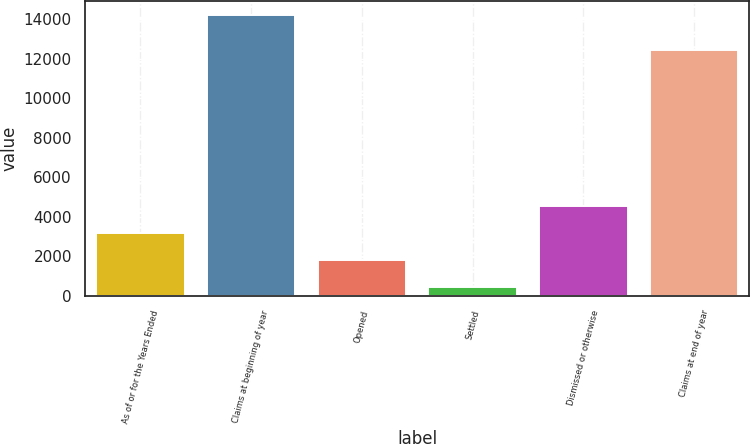Convert chart. <chart><loc_0><loc_0><loc_500><loc_500><bar_chart><fcel>As of or for the Years Ended<fcel>Claims at beginning of year<fcel>Opened<fcel>Settled<fcel>Dismissed or otherwise<fcel>Claims at end of year<nl><fcel>3183.8<fcel>14215<fcel>1804.9<fcel>426<fcel>4562.7<fcel>12454<nl></chart> 